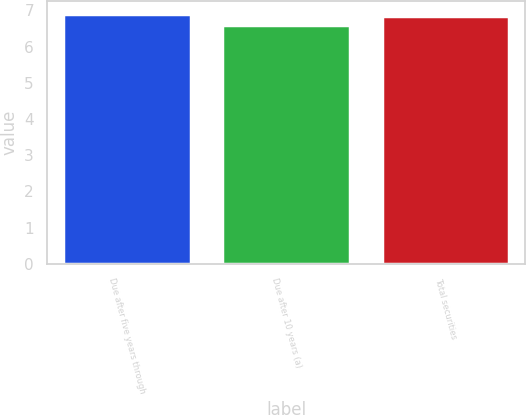Convert chart to OTSL. <chart><loc_0><loc_0><loc_500><loc_500><bar_chart><fcel>Due after five years through<fcel>Due after 10 years (a)<fcel>Total securities<nl><fcel>6.91<fcel>6.61<fcel>6.84<nl></chart> 